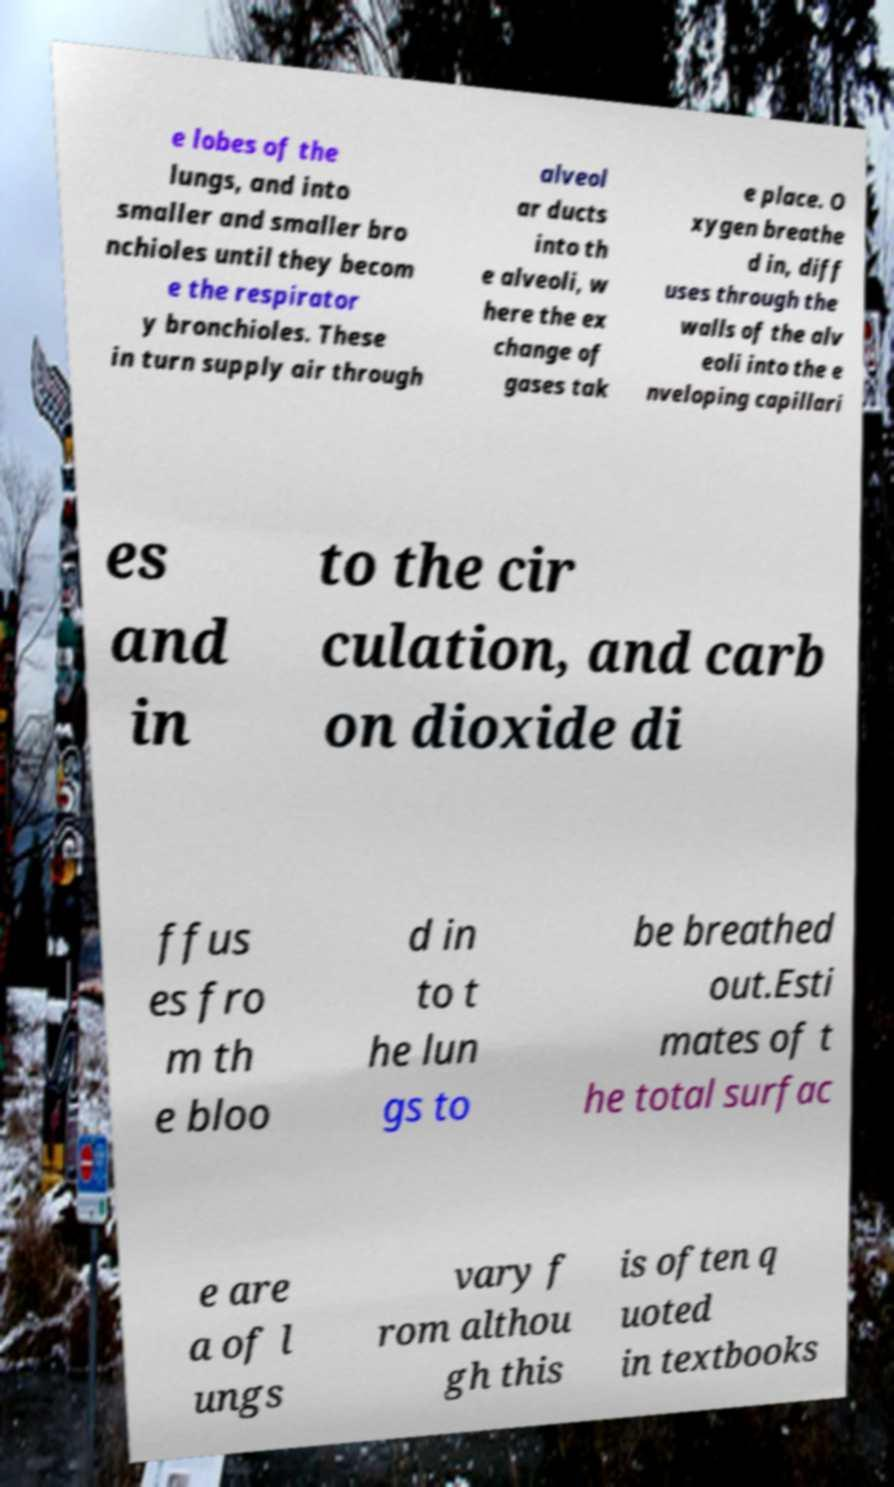Could you assist in decoding the text presented in this image and type it out clearly? e lobes of the lungs, and into smaller and smaller bro nchioles until they becom e the respirator y bronchioles. These in turn supply air through alveol ar ducts into th e alveoli, w here the ex change of gases tak e place. O xygen breathe d in, diff uses through the walls of the alv eoli into the e nveloping capillari es and in to the cir culation, and carb on dioxide di ffus es fro m th e bloo d in to t he lun gs to be breathed out.Esti mates of t he total surfac e are a of l ungs vary f rom althou gh this is often q uoted in textbooks 